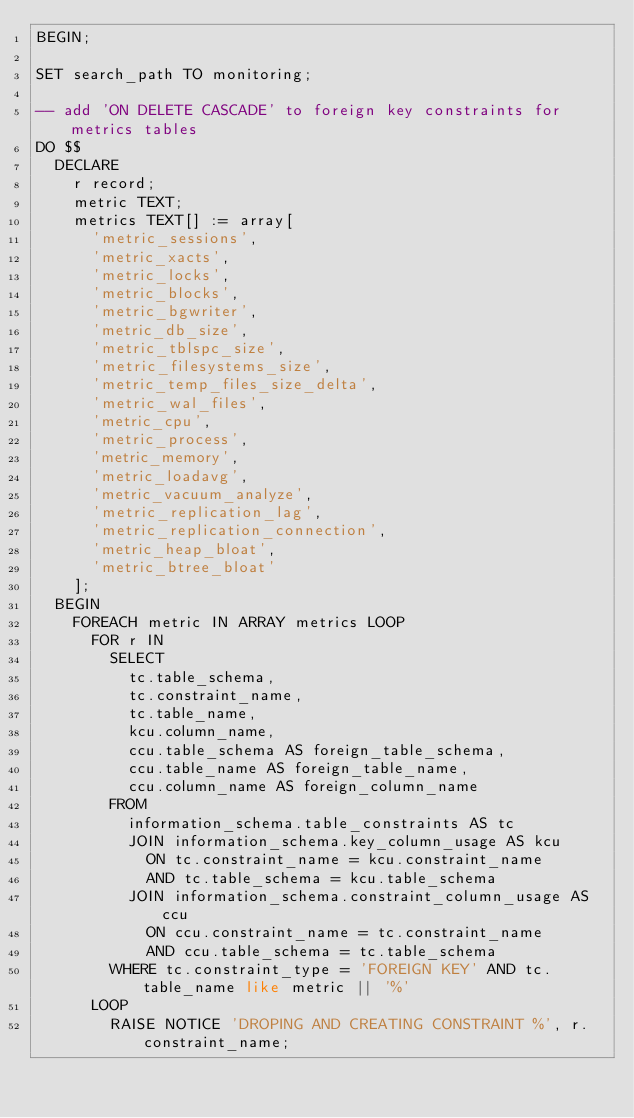Convert code to text. <code><loc_0><loc_0><loc_500><loc_500><_SQL_>BEGIN;

SET search_path TO monitoring;

-- add 'ON DELETE CASCADE' to foreign key constraints for metrics tables
DO $$
  DECLARE
    r record;
    metric TEXT;
    metrics TEXT[] := array[
      'metric_sessions',
      'metric_xacts',
      'metric_locks',
      'metric_blocks',
      'metric_bgwriter',
      'metric_db_size',
      'metric_tblspc_size',
      'metric_filesystems_size',
      'metric_temp_files_size_delta',
      'metric_wal_files',
      'metric_cpu',
      'metric_process',
      'metric_memory',
      'metric_loadavg',
      'metric_vacuum_analyze',
      'metric_replication_lag',
      'metric_replication_connection',
      'metric_heap_bloat',
      'metric_btree_bloat'
    ];
  BEGIN
    FOREACH metric IN ARRAY metrics LOOP
      FOR r IN
        SELECT
          tc.table_schema,
          tc.constraint_name,
          tc.table_name,
          kcu.column_name,
          ccu.table_schema AS foreign_table_schema,
          ccu.table_name AS foreign_table_name,
          ccu.column_name AS foreign_column_name
        FROM
          information_schema.table_constraints AS tc
          JOIN information_schema.key_column_usage AS kcu
            ON tc.constraint_name = kcu.constraint_name
            AND tc.table_schema = kcu.table_schema
          JOIN information_schema.constraint_column_usage AS ccu
            ON ccu.constraint_name = tc.constraint_name
            AND ccu.table_schema = tc.table_schema
        WHERE tc.constraint_type = 'FOREIGN KEY' AND tc.table_name like metric || '%'
      LOOP
        RAISE NOTICE 'DROPING AND CREATING CONSTRAINT %', r.constraint_name;</code> 